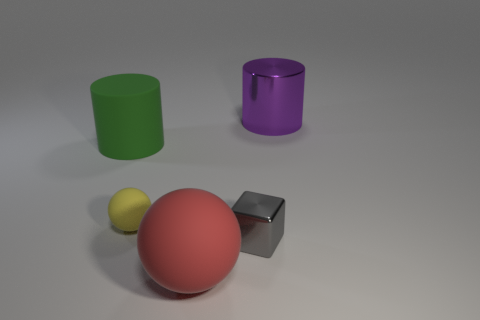Is there a large sphere that has the same material as the green cylinder?
Your answer should be very brief. Yes. There is a thing that is both behind the tiny rubber object and to the right of the tiny yellow rubber thing; what color is it?
Provide a succinct answer. Purple. How many other things are the same color as the shiny cylinder?
Offer a very short reply. 0. What is the cylinder that is to the left of the metal thing behind the large cylinder to the left of the gray shiny thing made of?
Ensure brevity in your answer.  Rubber. How many cylinders are either large gray rubber things or red rubber objects?
Keep it short and to the point. 0. There is a thing that is in front of the metal object that is left of the large purple cylinder; what number of shiny blocks are in front of it?
Your answer should be compact. 0. Do the big metallic object and the green rubber thing have the same shape?
Provide a short and direct response. Yes. Does the small object that is left of the block have the same material as the cylinder to the left of the purple cylinder?
Offer a very short reply. Yes. What number of things are either big rubber objects that are in front of the cube or rubber things behind the small metallic block?
Your response must be concise. 3. Are there any other things that have the same shape as the yellow thing?
Make the answer very short. Yes. 